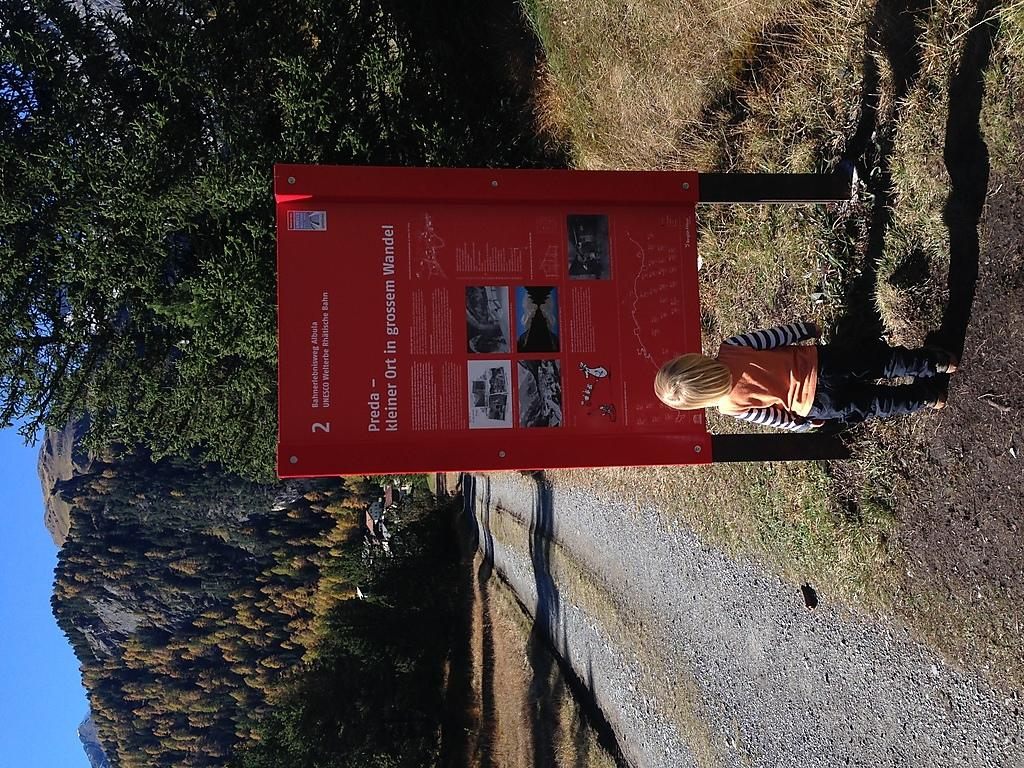What is the main subject of the image? There is a small girl standing in the image. What is in front of the girl? There is a green-colored board in front of the girl. What type of vegetation is visible at the bottom of the image? Green grass is visible at the bottom of the image. What can be seen to the left of the image? There are trees and mountains to the left of the image. What type of key is the girl holding in the image? There is no key present in the image; the girl is not holding anything. Can you see any worms crawling on the green grass in the image? There are no worms visible in the image; only the girl, the green-colored board, and the trees and mountains can be seen. 